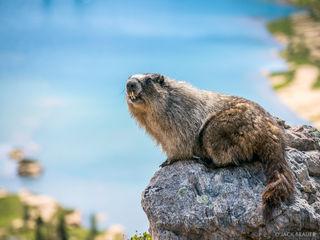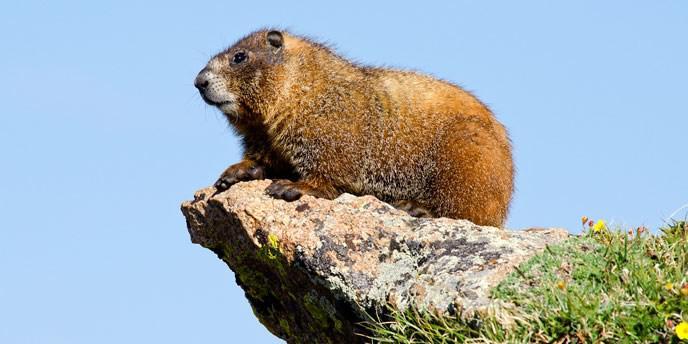The first image is the image on the left, the second image is the image on the right. For the images shown, is this caption "There are two marmots total." true? Answer yes or no. Yes. The first image is the image on the left, the second image is the image on the right. Given the left and right images, does the statement "One image includes multiple marmots that are standing on their hind legs and have their front paws raised." hold true? Answer yes or no. No. 